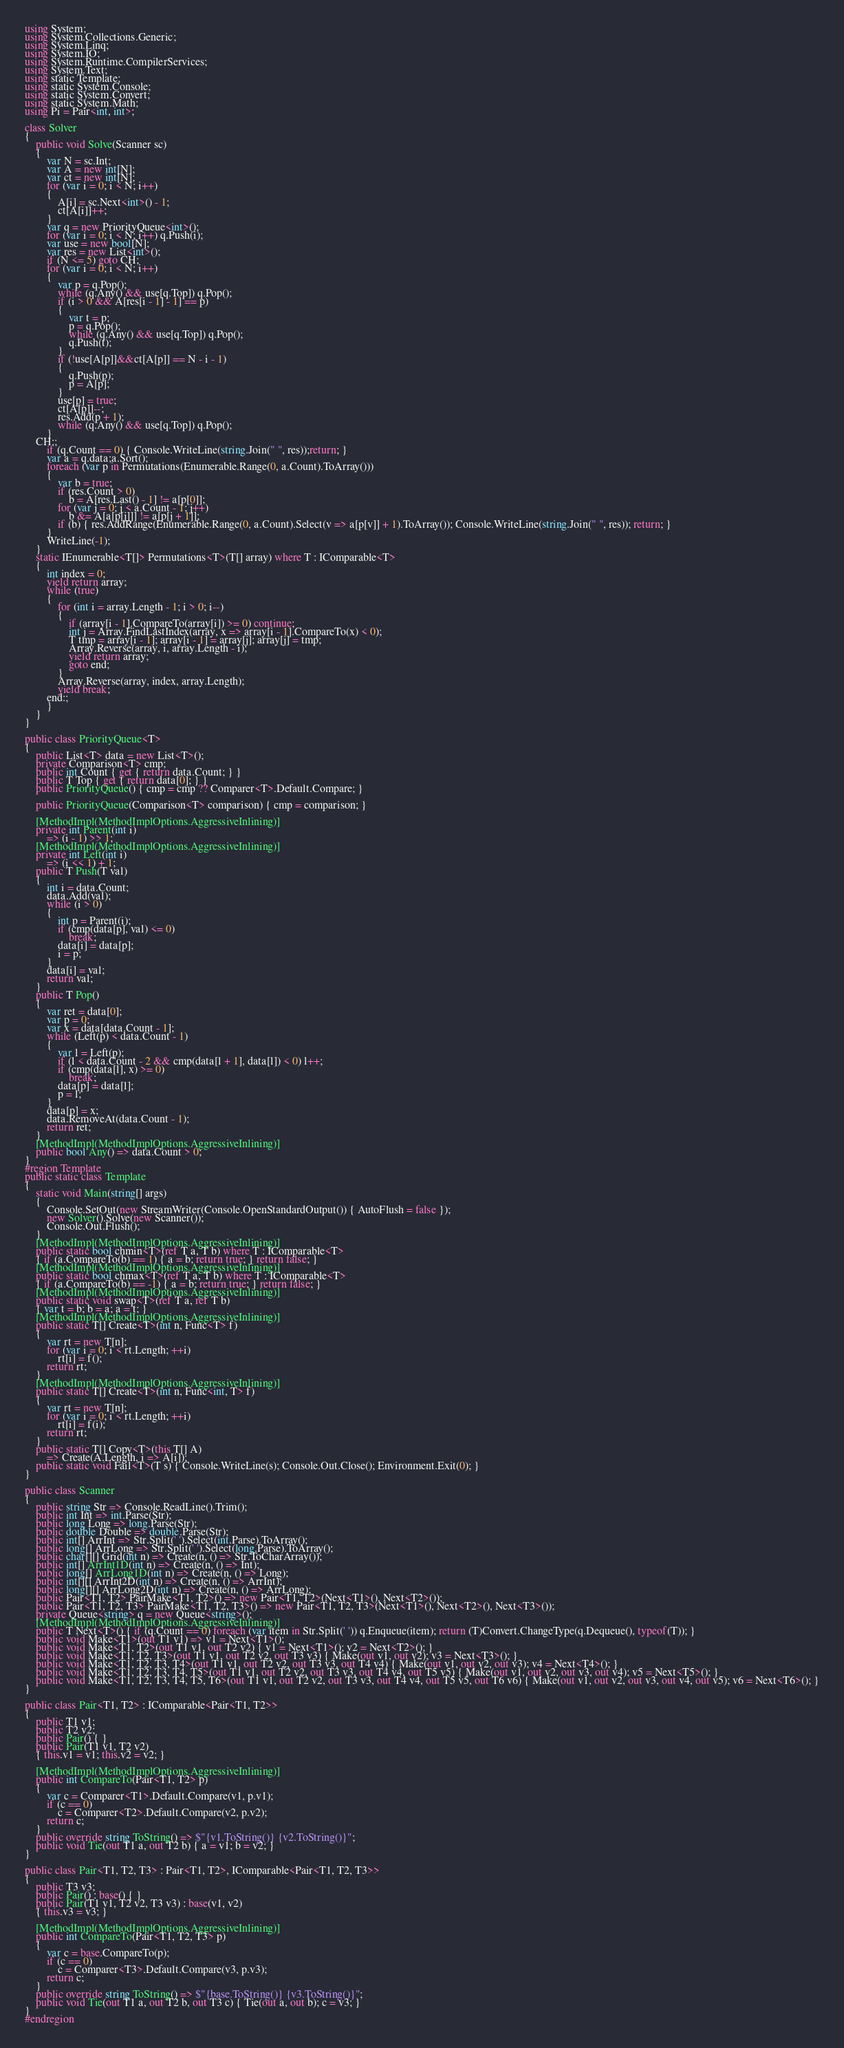<code> <loc_0><loc_0><loc_500><loc_500><_C#_>using System;
using System.Collections.Generic;
using System.Linq;
using System.IO;
using System.Runtime.CompilerServices;
using System.Text;
using static Template;
using static System.Console;
using static System.Convert;
using static System.Math;
using Pi = Pair<int, int>;

class Solver
{
    public void Solve(Scanner sc)
    {
        var N = sc.Int;
        var A = new int[N];
        var ct = new int[N];
        for (var i = 0; i < N; i++)
        {
            A[i] = sc.Next<int>() - 1;
            ct[A[i]]++;
        }
        var q = new PriorityQueue<int>();
        for (var i = 0; i < N; i++) q.Push(i);
        var use = new bool[N];
        var res = new List<int>();
        if (N <= 5) goto CH;
        for (var i = 0; i < N; i++)
        {
            var p = q.Pop();
            while (q.Any() && use[q.Top]) q.Pop(); 
            if (i > 0 && A[res[i - 1] - 1] == p)
            {
                var t = p;
                p = q.Pop();
                while (q.Any() && use[q.Top]) q.Pop();
                q.Push(t);
            }
            if (!use[A[p]]&&ct[A[p]] == N - i - 1)
            {
                q.Push(p);
                p = A[p];
            }
            use[p] = true;
            ct[A[p]]--;
            res.Add(p + 1);
            while (q.Any() && use[q.Top]) q.Pop();
        }
    CH:;
        if (q.Count == 0) { Console.WriteLine(string.Join(" ", res));return; }
        var a = q.data;a.Sort();
        foreach (var p in Permutations(Enumerable.Range(0, a.Count).ToArray()))
        {
            var b = true;
            if (res.Count > 0)
                b = A[res.Last() - 1] != a[p[0]];
            for (var j = 0; j < a.Count - 1; j++)
                b &= A[a[p[j]]] != a[p[j + 1]];
            if (b) { res.AddRange(Enumerable.Range(0, a.Count).Select(v => a[p[v]] + 1).ToArray()); Console.WriteLine(string.Join(" ", res)); return; }
        }
        WriteLine(-1);
    }
    static IEnumerable<T[]> Permutations<T>(T[] array) where T : IComparable<T>
    {
        int index = 0;
        yield return array;
        while (true)
        {
            for (int i = array.Length - 1; i > 0; i--)
            {
                if (array[i - 1].CompareTo(array[i]) >= 0) continue;
                int j = Array.FindLastIndex(array, x => array[i - 1].CompareTo(x) < 0);
                T tmp = array[i - 1]; array[i - 1] = array[j]; array[j] = tmp;
                Array.Reverse(array, i, array.Length - i);
                yield return array;
                goto end;
            }
            Array.Reverse(array, index, array.Length);
            yield break;
        end:;
        }
    }
}

public class PriorityQueue<T>
{
    public List<T> data = new List<T>();
    private Comparison<T> cmp;
    public int Count { get { return data.Count; } }
    public T Top { get { return data[0]; } }
    public PriorityQueue() { cmp = cmp ?? Comparer<T>.Default.Compare; }

    public PriorityQueue(Comparison<T> comparison) { cmp = comparison; }

    [MethodImpl(MethodImplOptions.AggressiveInlining)]
    private int Parent(int i)
        => (i - 1) >> 1;
    [MethodImpl(MethodImplOptions.AggressiveInlining)]
    private int Left(int i)
        => (i << 1) + 1;
    public T Push(T val)
    {
        int i = data.Count;
        data.Add(val);
        while (i > 0)
        {
            int p = Parent(i);
            if (cmp(data[p], val) <= 0)
                break;
            data[i] = data[p];
            i = p;
        }
        data[i] = val;
        return val;
    }
    public T Pop()
    {
        var ret = data[0];
        var p = 0;
        var x = data[data.Count - 1];
        while (Left(p) < data.Count - 1)
        {
            var l = Left(p);
            if (l < data.Count - 2 && cmp(data[l + 1], data[l]) < 0) l++;
            if (cmp(data[l], x) >= 0)
                break;
            data[p] = data[l];
            p = l;
        }
        data[p] = x;
        data.RemoveAt(data.Count - 1);
        return ret;
    }
    [MethodImpl(MethodImplOptions.AggressiveInlining)]
    public bool Any() => data.Count > 0;
}
#region Template
public static class Template
{
    static void Main(string[] args)
    {
        Console.SetOut(new StreamWriter(Console.OpenStandardOutput()) { AutoFlush = false });
        new Solver().Solve(new Scanner());
        Console.Out.Flush();
    }
    [MethodImpl(MethodImplOptions.AggressiveInlining)]
    public static bool chmin<T>(ref T a, T b) where T : IComparable<T>
    { if (a.CompareTo(b) == 1) { a = b; return true; } return false; }
    [MethodImpl(MethodImplOptions.AggressiveInlining)]
    public static bool chmax<T>(ref T a, T b) where T : IComparable<T>
    { if (a.CompareTo(b) == -1) { a = b; return true; } return false; }
    [MethodImpl(MethodImplOptions.AggressiveInlining)]
    public static void swap<T>(ref T a, ref T b)
    { var t = b; b = a; a = t; }
    [MethodImpl(MethodImplOptions.AggressiveInlining)]
    public static T[] Create<T>(int n, Func<T> f)
    {
        var rt = new T[n];
        for (var i = 0; i < rt.Length; ++i)
            rt[i] = f();
        return rt;
    }
    [MethodImpl(MethodImplOptions.AggressiveInlining)]
    public static T[] Create<T>(int n, Func<int, T> f)
    {
        var rt = new T[n];
        for (var i = 0; i < rt.Length; ++i)
            rt[i] = f(i);
        return rt;
    }
    public static T[] Copy<T>(this T[] A)
        => Create(A.Length, i => A[i]);
    public static void Fail<T>(T s) { Console.WriteLine(s); Console.Out.Close(); Environment.Exit(0); }
}

public class Scanner
{
    public string Str => Console.ReadLine().Trim();
    public int Int => int.Parse(Str);
    public long Long => long.Parse(Str);
    public double Double => double.Parse(Str);
    public int[] ArrInt => Str.Split(' ').Select(int.Parse).ToArray();
    public long[] ArrLong => Str.Split(' ').Select(long.Parse).ToArray();
    public char[][] Grid(int n) => Create(n, () => Str.ToCharArray());
    public int[] ArrInt1D(int n) => Create(n, () => Int);
    public long[] ArrLong1D(int n) => Create(n, () => Long);
    public int[][] ArrInt2D(int n) => Create(n, () => ArrInt);
    public long[][] ArrLong2D(int n) => Create(n, () => ArrLong);
    public Pair<T1, T2> PairMake<T1, T2>() => new Pair<T1, T2>(Next<T1>(), Next<T2>());
    public Pair<T1, T2, T3> PairMake<T1, T2, T3>() => new Pair<T1, T2, T3>(Next<T1>(), Next<T2>(), Next<T3>());
    private Queue<string> q = new Queue<string>();
    [MethodImpl(MethodImplOptions.AggressiveInlining)]
    public T Next<T>() { if (q.Count == 0) foreach (var item in Str.Split(' ')) q.Enqueue(item); return (T)Convert.ChangeType(q.Dequeue(), typeof(T)); }
    public void Make<T1>(out T1 v1) => v1 = Next<T1>();
    public void Make<T1, T2>(out T1 v1, out T2 v2) { v1 = Next<T1>(); v2 = Next<T2>(); }
    public void Make<T1, T2, T3>(out T1 v1, out T2 v2, out T3 v3) { Make(out v1, out v2); v3 = Next<T3>(); }
    public void Make<T1, T2, T3, T4>(out T1 v1, out T2 v2, out T3 v3, out T4 v4) { Make(out v1, out v2, out v3); v4 = Next<T4>(); }
    public void Make<T1, T2, T3, T4, T5>(out T1 v1, out T2 v2, out T3 v3, out T4 v4, out T5 v5) { Make(out v1, out v2, out v3, out v4); v5 = Next<T5>(); }
    public void Make<T1, T2, T3, T4, T5, T6>(out T1 v1, out T2 v2, out T3 v3, out T4 v4, out T5 v5, out T6 v6) { Make(out v1, out v2, out v3, out v4, out v5); v6 = Next<T6>(); }
}

public class Pair<T1, T2> : IComparable<Pair<T1, T2>>
{
    public T1 v1;
    public T2 v2;
    public Pair() { }
    public Pair(T1 v1, T2 v2)
    { this.v1 = v1; this.v2 = v2; }

    [MethodImpl(MethodImplOptions.AggressiveInlining)]
    public int CompareTo(Pair<T1, T2> p)
    {
        var c = Comparer<T1>.Default.Compare(v1, p.v1);
        if (c == 0)
            c = Comparer<T2>.Default.Compare(v2, p.v2);
        return c;
    }
    public override string ToString() => $"{v1.ToString()} {v2.ToString()}";
    public void Tie(out T1 a, out T2 b) { a = v1; b = v2; }
}

public class Pair<T1, T2, T3> : Pair<T1, T2>, IComparable<Pair<T1, T2, T3>>
{
    public T3 v3;
    public Pair() : base() { }
    public Pair(T1 v1, T2 v2, T3 v3) : base(v1, v2)
    { this.v3 = v3; }

    [MethodImpl(MethodImplOptions.AggressiveInlining)]
    public int CompareTo(Pair<T1, T2, T3> p)
    {
        var c = base.CompareTo(p);
        if (c == 0)
            c = Comparer<T3>.Default.Compare(v3, p.v3);
        return c;
    }
    public override string ToString() => $"{base.ToString()} {v3.ToString()}";
    public void Tie(out T1 a, out T2 b, out T3 c) { Tie(out a, out b); c = v3; }
}
#endregion
</code> 